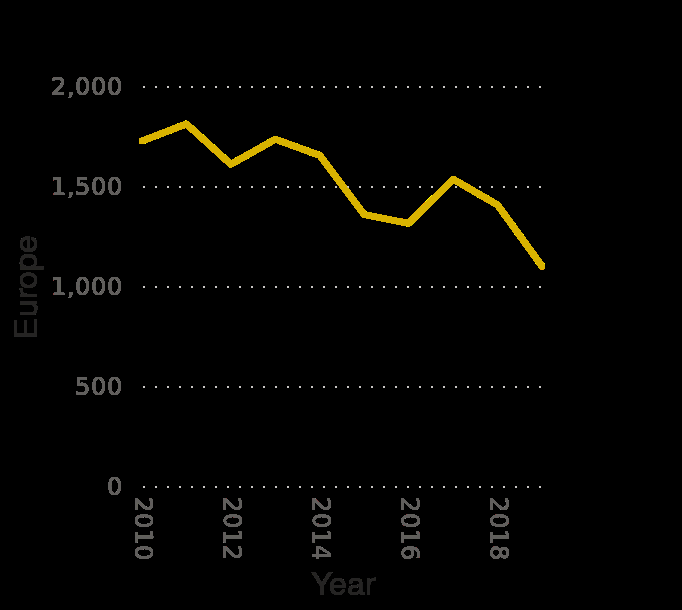<image>
Which region is represented on the y-axis of the line plot?  The y-axis of the line plot represents "Europe". 